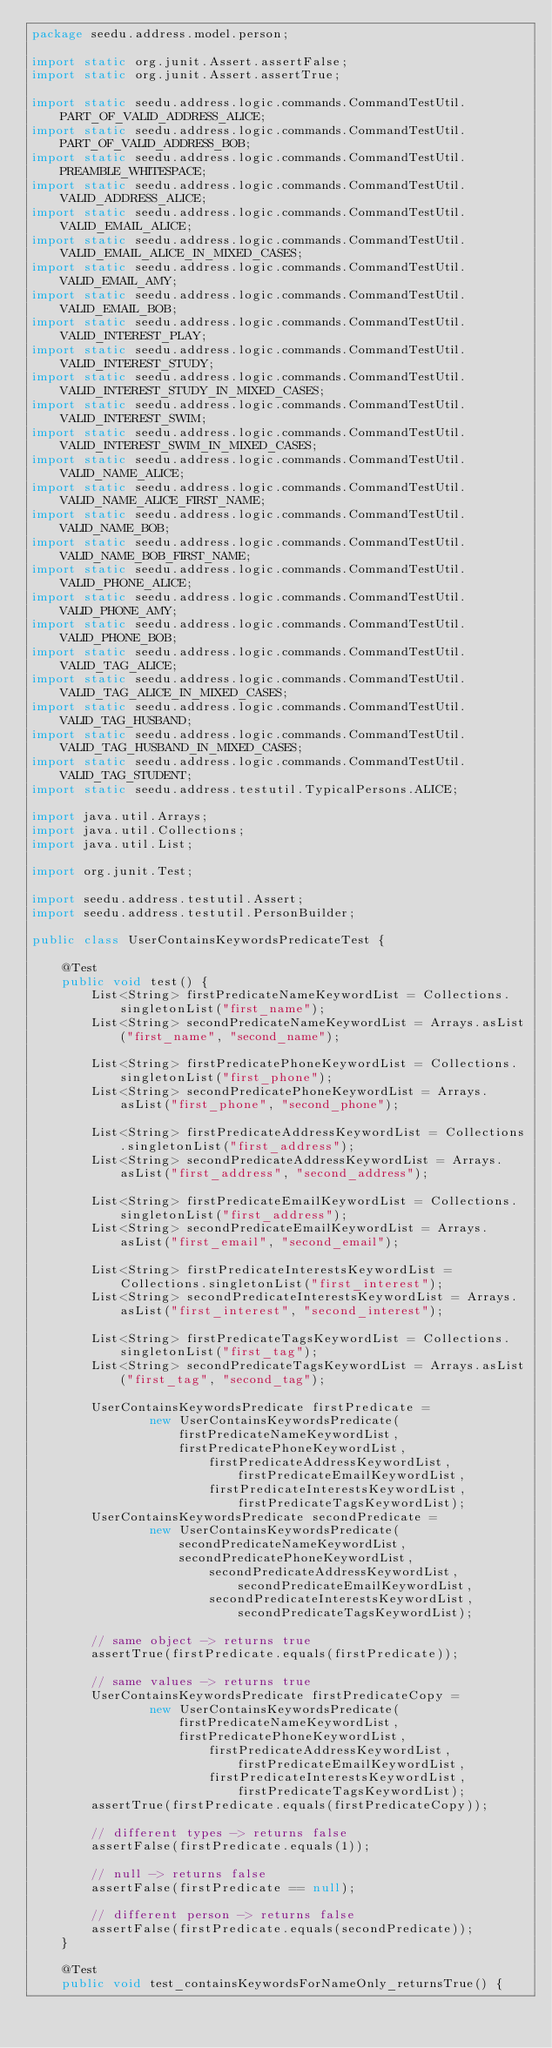Convert code to text. <code><loc_0><loc_0><loc_500><loc_500><_Java_>package seedu.address.model.person;

import static org.junit.Assert.assertFalse;
import static org.junit.Assert.assertTrue;

import static seedu.address.logic.commands.CommandTestUtil.PART_OF_VALID_ADDRESS_ALICE;
import static seedu.address.logic.commands.CommandTestUtil.PART_OF_VALID_ADDRESS_BOB;
import static seedu.address.logic.commands.CommandTestUtil.PREAMBLE_WHITESPACE;
import static seedu.address.logic.commands.CommandTestUtil.VALID_ADDRESS_ALICE;
import static seedu.address.logic.commands.CommandTestUtil.VALID_EMAIL_ALICE;
import static seedu.address.logic.commands.CommandTestUtil.VALID_EMAIL_ALICE_IN_MIXED_CASES;
import static seedu.address.logic.commands.CommandTestUtil.VALID_EMAIL_AMY;
import static seedu.address.logic.commands.CommandTestUtil.VALID_EMAIL_BOB;
import static seedu.address.logic.commands.CommandTestUtil.VALID_INTEREST_PLAY;
import static seedu.address.logic.commands.CommandTestUtil.VALID_INTEREST_STUDY;
import static seedu.address.logic.commands.CommandTestUtil.VALID_INTEREST_STUDY_IN_MIXED_CASES;
import static seedu.address.logic.commands.CommandTestUtil.VALID_INTEREST_SWIM;
import static seedu.address.logic.commands.CommandTestUtil.VALID_INTEREST_SWIM_IN_MIXED_CASES;
import static seedu.address.logic.commands.CommandTestUtil.VALID_NAME_ALICE;
import static seedu.address.logic.commands.CommandTestUtil.VALID_NAME_ALICE_FIRST_NAME;
import static seedu.address.logic.commands.CommandTestUtil.VALID_NAME_BOB;
import static seedu.address.logic.commands.CommandTestUtil.VALID_NAME_BOB_FIRST_NAME;
import static seedu.address.logic.commands.CommandTestUtil.VALID_PHONE_ALICE;
import static seedu.address.logic.commands.CommandTestUtil.VALID_PHONE_AMY;
import static seedu.address.logic.commands.CommandTestUtil.VALID_PHONE_BOB;
import static seedu.address.logic.commands.CommandTestUtil.VALID_TAG_ALICE;
import static seedu.address.logic.commands.CommandTestUtil.VALID_TAG_ALICE_IN_MIXED_CASES;
import static seedu.address.logic.commands.CommandTestUtil.VALID_TAG_HUSBAND;
import static seedu.address.logic.commands.CommandTestUtil.VALID_TAG_HUSBAND_IN_MIXED_CASES;
import static seedu.address.logic.commands.CommandTestUtil.VALID_TAG_STUDENT;
import static seedu.address.testutil.TypicalPersons.ALICE;

import java.util.Arrays;
import java.util.Collections;
import java.util.List;

import org.junit.Test;

import seedu.address.testutil.Assert;
import seedu.address.testutil.PersonBuilder;

public class UserContainsKeywordsPredicateTest {

    @Test
    public void test() {
        List<String> firstPredicateNameKeywordList = Collections.singletonList("first_name");
        List<String> secondPredicateNameKeywordList = Arrays.asList("first_name", "second_name");

        List<String> firstPredicatePhoneKeywordList = Collections.singletonList("first_phone");
        List<String> secondPredicatePhoneKeywordList = Arrays.asList("first_phone", "second_phone");

        List<String> firstPredicateAddressKeywordList = Collections.singletonList("first_address");
        List<String> secondPredicateAddressKeywordList = Arrays.asList("first_address", "second_address");

        List<String> firstPredicateEmailKeywordList = Collections.singletonList("first_address");
        List<String> secondPredicateEmailKeywordList = Arrays.asList("first_email", "second_email");

        List<String> firstPredicateInterestsKeywordList = Collections.singletonList("first_interest");
        List<String> secondPredicateInterestsKeywordList = Arrays.asList("first_interest", "second_interest");

        List<String> firstPredicateTagsKeywordList = Collections.singletonList("first_tag");
        List<String> secondPredicateTagsKeywordList = Arrays.asList("first_tag", "second_tag");

        UserContainsKeywordsPredicate firstPredicate =
                new UserContainsKeywordsPredicate(firstPredicateNameKeywordList, firstPredicatePhoneKeywordList,
                        firstPredicateAddressKeywordList, firstPredicateEmailKeywordList,
                        firstPredicateInterestsKeywordList, firstPredicateTagsKeywordList);
        UserContainsKeywordsPredicate secondPredicate =
                new UserContainsKeywordsPredicate(secondPredicateNameKeywordList, secondPredicatePhoneKeywordList,
                        secondPredicateAddressKeywordList, secondPredicateEmailKeywordList,
                        secondPredicateInterestsKeywordList, secondPredicateTagsKeywordList);

        // same object -> returns true
        assertTrue(firstPredicate.equals(firstPredicate));

        // same values -> returns true
        UserContainsKeywordsPredicate firstPredicateCopy =
                new UserContainsKeywordsPredicate(firstPredicateNameKeywordList, firstPredicatePhoneKeywordList,
                        firstPredicateAddressKeywordList, firstPredicateEmailKeywordList,
                        firstPredicateInterestsKeywordList, firstPredicateTagsKeywordList);
        assertTrue(firstPredicate.equals(firstPredicateCopy));

        // different types -> returns false
        assertFalse(firstPredicate.equals(1));

        // null -> returns false
        assertFalse(firstPredicate == null);

        // different person -> returns false
        assertFalse(firstPredicate.equals(secondPredicate));
    }

    @Test
    public void test_containsKeywordsForNameOnly_returnsTrue() {</code> 